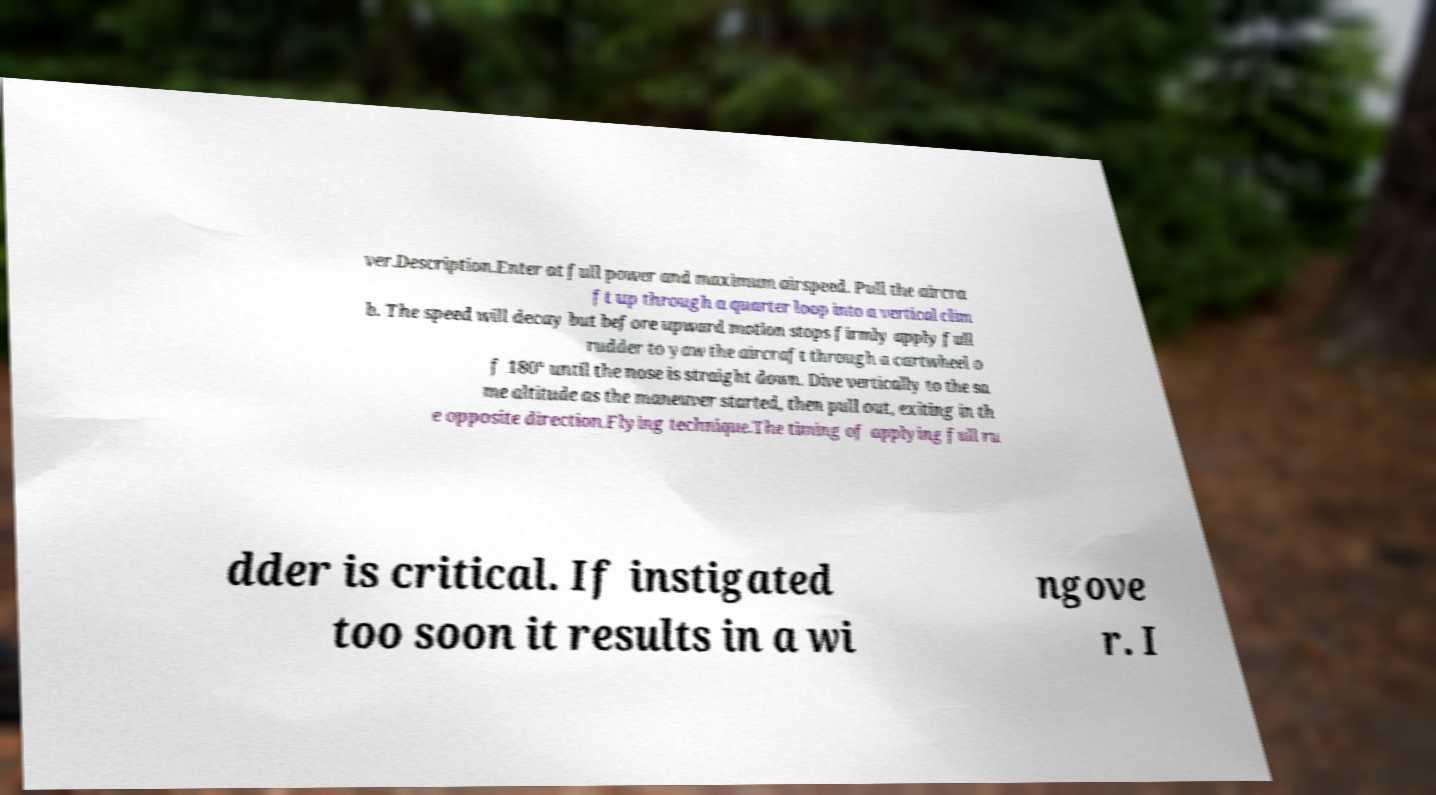Please identify and transcribe the text found in this image. ver.Description.Enter at full power and maximum airspeed. Pull the aircra ft up through a quarter loop into a vertical clim b. The speed will decay but before upward motion stops firmly apply full rudder to yaw the aircraft through a cartwheel o f 180° until the nose is straight down. Dive vertically to the sa me altitude as the maneuver started, then pull out, exiting in th e opposite direction.Flying technique.The timing of applying full ru dder is critical. If instigated too soon it results in a wi ngove r. I 